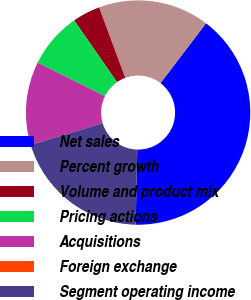Convert chart. <chart><loc_0><loc_0><loc_500><loc_500><pie_chart><fcel>Net sales<fcel>Percent growth<fcel>Volume and product mix<fcel>Pricing actions<fcel>Acquisitions<fcel>Foreign exchange<fcel>Segment operating income<nl><fcel>40.0%<fcel>16.0%<fcel>4.0%<fcel>8.0%<fcel>12.0%<fcel>0.0%<fcel>20.0%<nl></chart> 